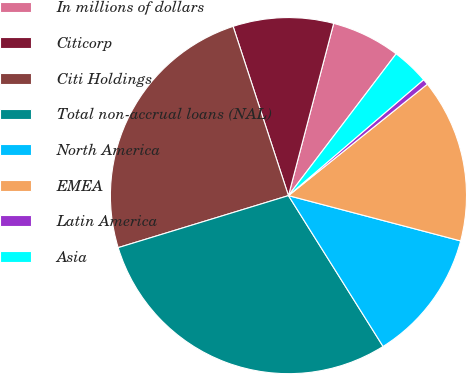Convert chart. <chart><loc_0><loc_0><loc_500><loc_500><pie_chart><fcel>In millions of dollars<fcel>Citicorp<fcel>Citi Holdings<fcel>Total non-accrual loans (NAL)<fcel>North America<fcel>EMEA<fcel>Latin America<fcel>Asia<nl><fcel>6.25%<fcel>9.12%<fcel>24.69%<fcel>29.2%<fcel>11.99%<fcel>14.86%<fcel>0.52%<fcel>3.38%<nl></chart> 